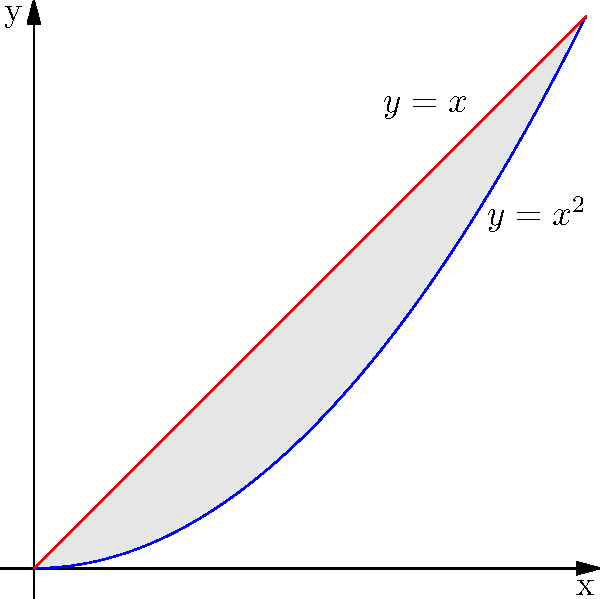As a data scientist optimizing audience targeting for travel campaigns, you're analyzing the effectiveness of different promotional strategies. You decide to model the impact using a geometric approach. Consider the region bounded by the curves $y=x^2$ and $y=x$ from $x=0$ to $x=1$. If this region is rotated around the y-axis, what is the volume of the resulting solid? Round your answer to three decimal places. To solve this problem, we'll use the shell method for calculating the volume of a solid of revolution. The steps are as follows:

1) The shell method formula is:
   $$V = 2\pi \int_a^b x[f(x) - g(x)]dx$$
   where $f(x)$ is the outer function and $g(x)$ is the inner function.

2) In this case, $f(x) = x$ and $g(x) = x^2$, with $a=0$ and $b=1$.

3) Substituting into the formula:
   $$V = 2\pi \int_0^1 x[x - x^2]dx$$

4) Simplify the integrand:
   $$V = 2\pi \int_0^1 (x^2 - x^3)dx$$

5) Integrate:
   $$V = 2\pi [\frac{x^3}{3} - \frac{x^4}{4}]_0^1$$

6) Evaluate the definite integral:
   $$V = 2\pi [(\frac{1}{3} - \frac{1}{4}) - (0 - 0)]$$
   $$V = 2\pi [\frac{1}{12}]$$

7) Simplify:
   $$V = \frac{\pi}{6}$$

8) Calculate and round to three decimal places:
   $$V \approx 0.524$$
Answer: 0.524 